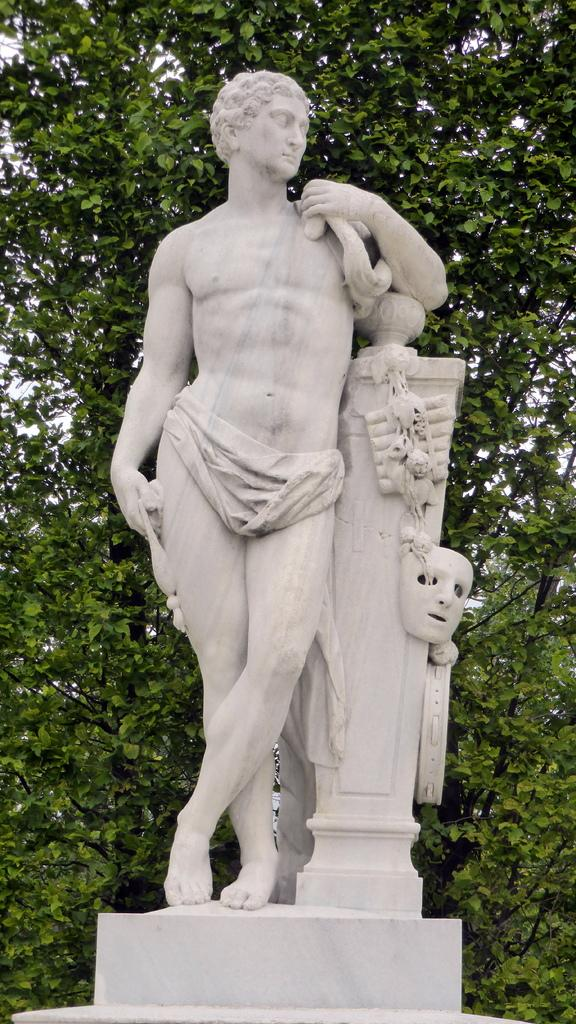What is the main subject of the image? There is a statue of a man in the image. How is the statue positioned in the image? The statue is standing. What can be seen in the background of the image? There are trees in the background of the image. What type of protest is taking place in the image? There is no protest present in the image; it features a statue of a man standing with trees in the background. Can you tell me how many pigs are visible in the image? There are no pigs present in the image. 